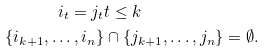Convert formula to latex. <formula><loc_0><loc_0><loc_500><loc_500>i _ { t } = j _ { t } & t \leq k \\ \{ i _ { k + 1 } , \dots , i _ { n } \} & \cap \{ j _ { k + 1 } , \dots , j _ { n } \} = \emptyset .</formula> 